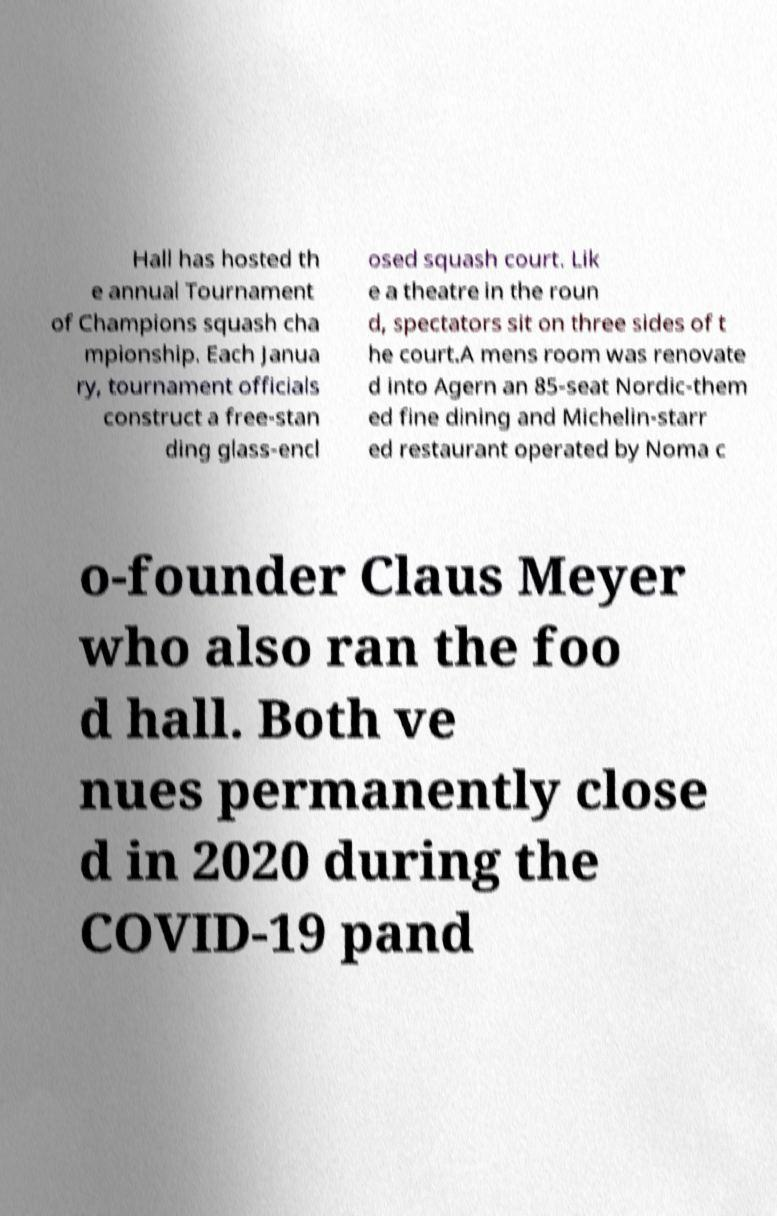Can you read and provide the text displayed in the image?This photo seems to have some interesting text. Can you extract and type it out for me? Hall has hosted th e annual Tournament of Champions squash cha mpionship. Each Janua ry, tournament officials construct a free-stan ding glass-encl osed squash court. Lik e a theatre in the roun d, spectators sit on three sides of t he court.A mens room was renovate d into Agern an 85-seat Nordic-them ed fine dining and Michelin-starr ed restaurant operated by Noma c o-founder Claus Meyer who also ran the foo d hall. Both ve nues permanently close d in 2020 during the COVID-19 pand 